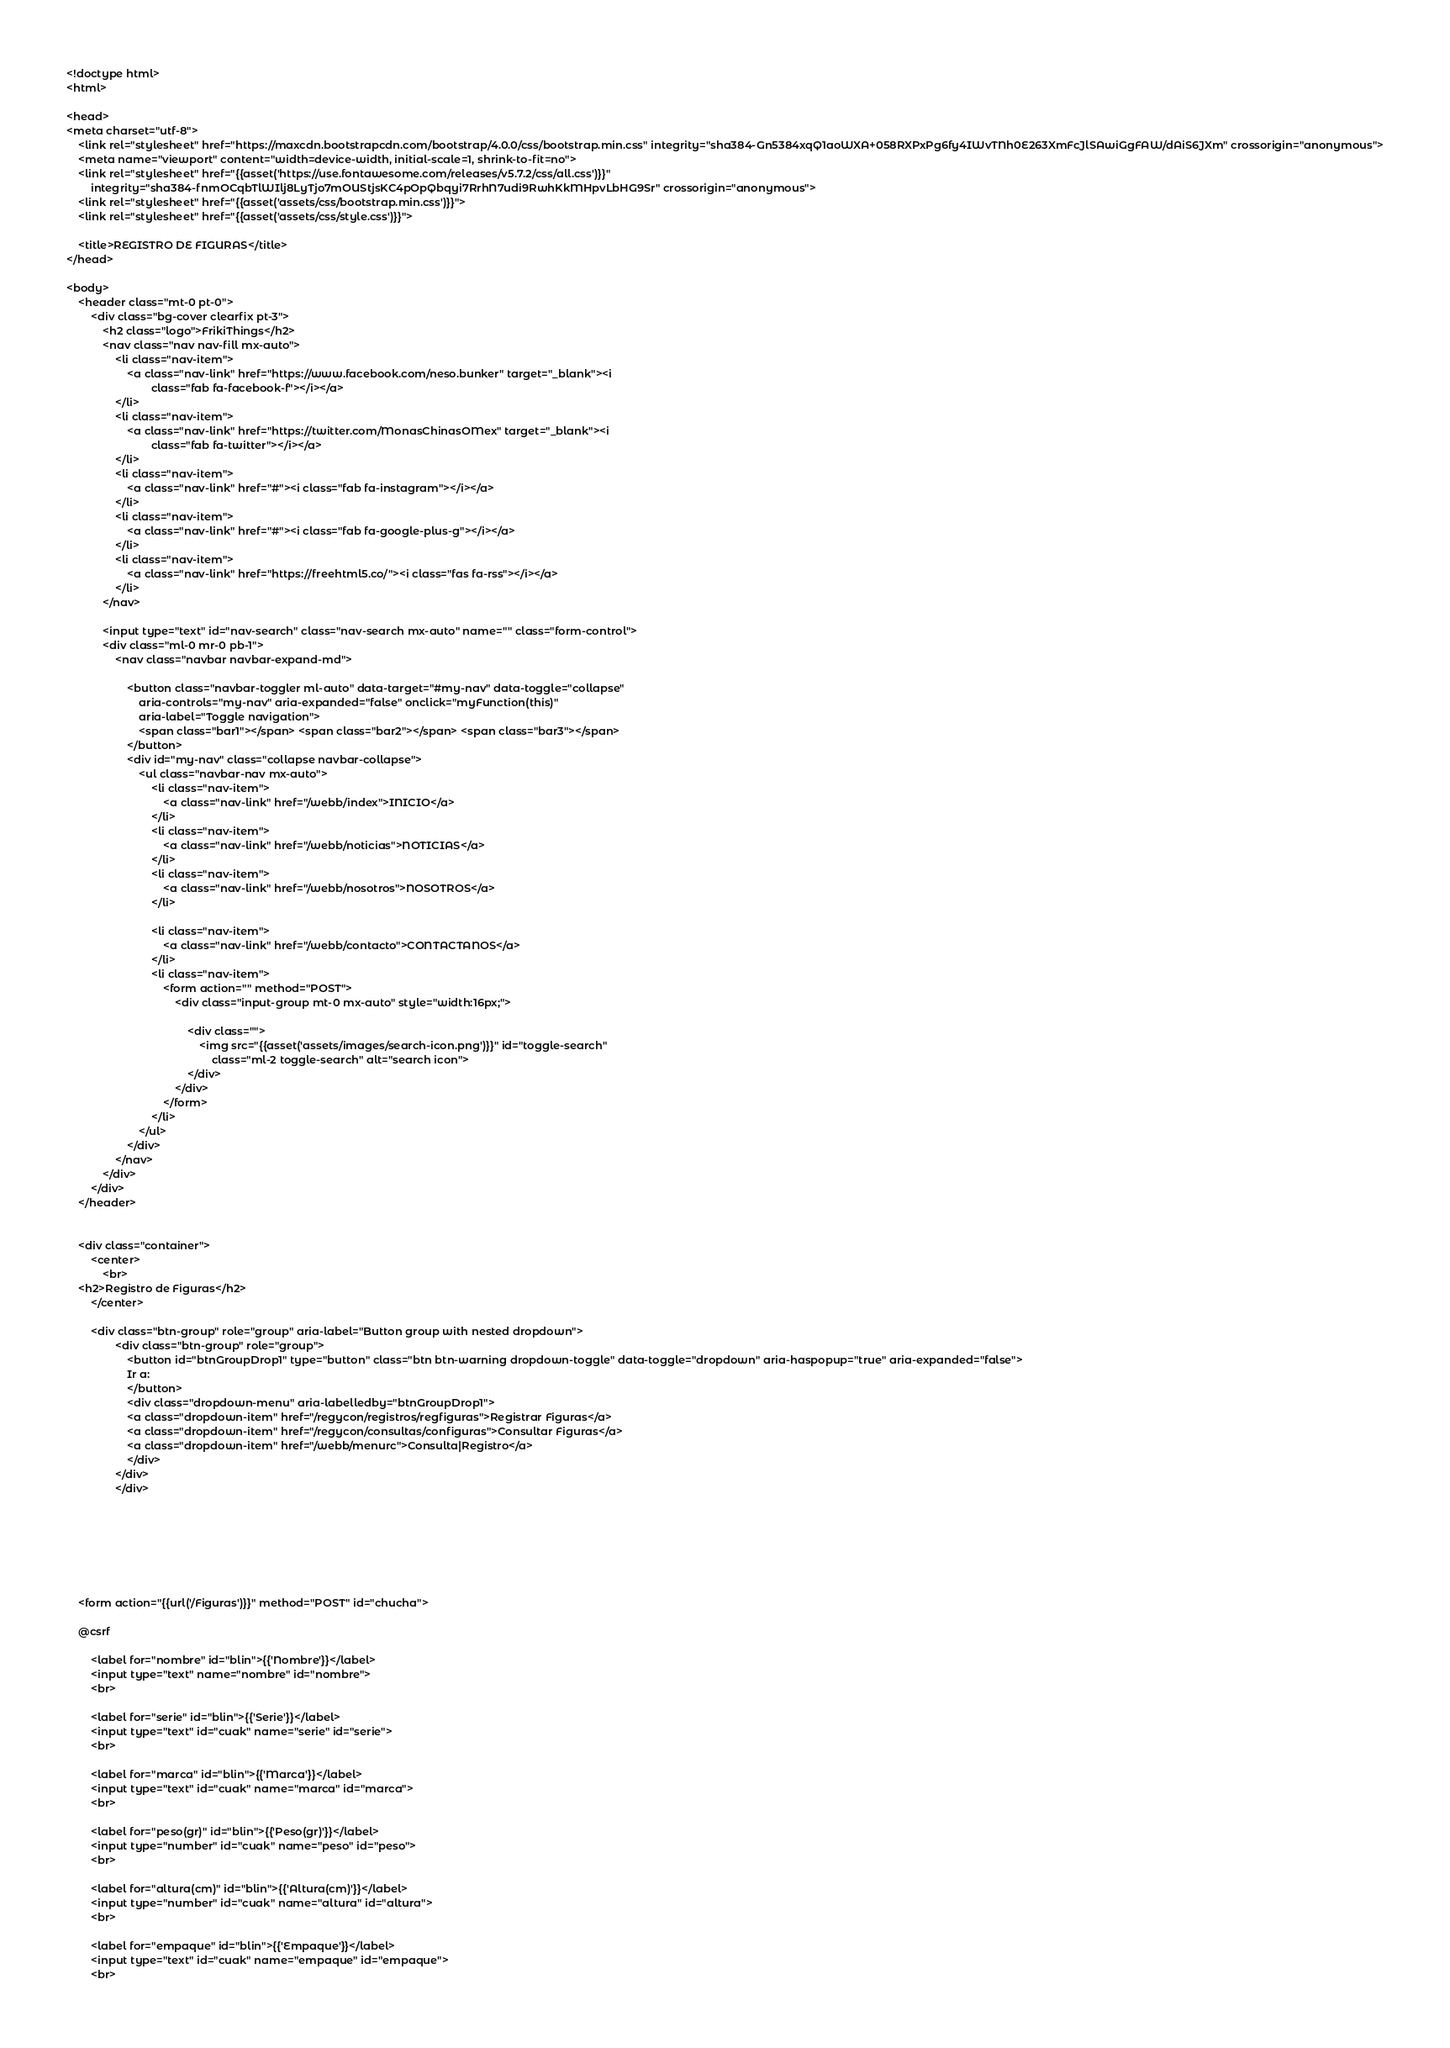<code> <loc_0><loc_0><loc_500><loc_500><_PHP_>
<!doctype html>
<html>

<head>
<meta charset="utf-8">
    <link rel="stylesheet" href="https://maxcdn.bootstrapcdn.com/bootstrap/4.0.0/css/bootstrap.min.css" integrity="sha384-Gn5384xqQ1aoWXA+058RXPxPg6fy4IWvTNh0E263XmFcJlSAwiGgFAW/dAiS6JXm" crossorigin="anonymous">
    <meta name="viewport" content="width=device-width, initial-scale=1, shrink-to-fit=no">
    <link rel="stylesheet" href="{{asset('https://use.fontawesome.com/releases/v5.7.2/css/all.css')}}"
        integrity="sha384-fnmOCqbTlWIlj8LyTjo7mOUStjsKC4pOpQbqyi7RrhN7udi9RwhKkMHpvLbHG9Sr" crossorigin="anonymous">
    <link rel="stylesheet" href="{{asset('assets/css/bootstrap.min.css')}}">
    <link rel="stylesheet" href="{{asset('assets/css/style.css')}}">
    
    <title>REGISTRO DE FIGURAS</title>
</head>

<body>
    <header class="mt-0 pt-0">
        <div class="bg-cover clearfix pt-3">
            <h2 class="logo">FrikiThings</h2>
            <nav class="nav nav-fill mx-auto">
                <li class="nav-item">
                    <a class="nav-link" href="https://www.facebook.com/neso.bunker" target="_blank"><i
                            class="fab fa-facebook-f"></i></a>
                </li>
                <li class="nav-item">
                    <a class="nav-link" href="https://twitter.com/MonasChinasOMex" target="_blank"><i
                            class="fab fa-twitter"></i></a>
                </li>
                <li class="nav-item">
                    <a class="nav-link" href="#"><i class="fab fa-instagram"></i></a>
                </li>
                <li class="nav-item">
                    <a class="nav-link" href="#"><i class="fab fa-google-plus-g"></i></a>
                </li>
                <li class="nav-item">
                    <a class="nav-link" href="https://freehtml5.co/"><i class="fas fa-rss"></i></a>
                </li>
            </nav>

            <input type="text" id="nav-search" class="nav-search mx-auto" name="" class="form-control">
            <div class="ml-0 mr-0 pb-1">
                <nav class="navbar navbar-expand-md">

                    <button class="navbar-toggler ml-auto" data-target="#my-nav" data-toggle="collapse"
                        aria-controls="my-nav" aria-expanded="false" onclick="myFunction(this)"
                        aria-label="Toggle navigation">
                        <span class="bar1"></span> <span class="bar2"></span> <span class="bar3"></span>
                    </button>
                    <div id="my-nav" class="collapse navbar-collapse">
                        <ul class="navbar-nav mx-auto">
                            <li class="nav-item">
                                <a class="nav-link" href="/webb/index">INICIO</a>
                            </li>
                            <li class="nav-item">
                                <a class="nav-link" href="/webb/noticias">NOTICIAS</a>
                            </li>
                            <li class="nav-item">
                                <a class="nav-link" href="/webb/nosotros">NOSOTROS</a>
                            </li>
                            
                            <li class="nav-item">
                                <a class="nav-link" href="/webb/contacto">CONTACTANOS</a>
                            </li>
                            <li class="nav-item">
                                <form action="" method="POST">
                                    <div class="input-group mt-0 mx-auto" style="width:16px;">

                                        <div class="">
                                            <img src="{{asset('assets/images/search-icon.png')}}" id="toggle-search"
                                                class="ml-2 toggle-search" alt="search icon">
                                        </div>
                                    </div>
                                </form>
                            </li>
                        </ul>
                    </div>
                </nav>
            </div>
        </div>
    </header>


    <div class="container">
        <center>
            <br>
    <h2>Registro de Figuras</h2>
        </center>

        <div class="btn-group" role="group" aria-label="Button group with nested dropdown">
                <div class="btn-group" role="group">
                    <button id="btnGroupDrop1" type="button" class="btn btn-warning dropdown-toggle" data-toggle="dropdown" aria-haspopup="true" aria-expanded="false">
                    Ir a:
                    </button>
                    <div class="dropdown-menu" aria-labelledby="btnGroupDrop1">
                    <a class="dropdown-item" href="/regycon/registros/regfiguras">Registrar Figuras</a>
                    <a class="dropdown-item" href="/regycon/consultas/configuras">Consultar Figuras</a>
                    <a class="dropdown-item" href="/webb/menurc">Consulta|Registro</a>
                    </div>
                </div>
                </div>

                


        


    <form action="{{url('/Figuras')}}" method="POST" id="chucha">

    @csrf

        <label for="nombre" id="blin">{{'Nombre'}}</label>
        <input type="text" name="nombre" id="nombre">
        <br>

        <label for="serie" id="blin">{{'Serie'}}</label>
        <input type="text" id="cuak" name="serie" id="serie">
        <br>

        <label for="marca" id="blin">{{'Marca'}}</label>
        <input type="text" id="cuak" name="marca" id="marca">
        <br>

        <label for="peso(gr)" id="blin">{{'Peso(gr)'}}</label>
        <input type="number" id="cuak" name="peso" id="peso">
        <br>

        <label for="altura(cm)" id="blin">{{'Altura(cm)'}}</label>
        <input type="number" id="cuak" name="altura" id="altura">
        <br>

        <label for="empaque" id="blin">{{'Empaque'}}</label>
        <input type="text" id="cuak" name="empaque" id="empaque">
        <br>
</code> 